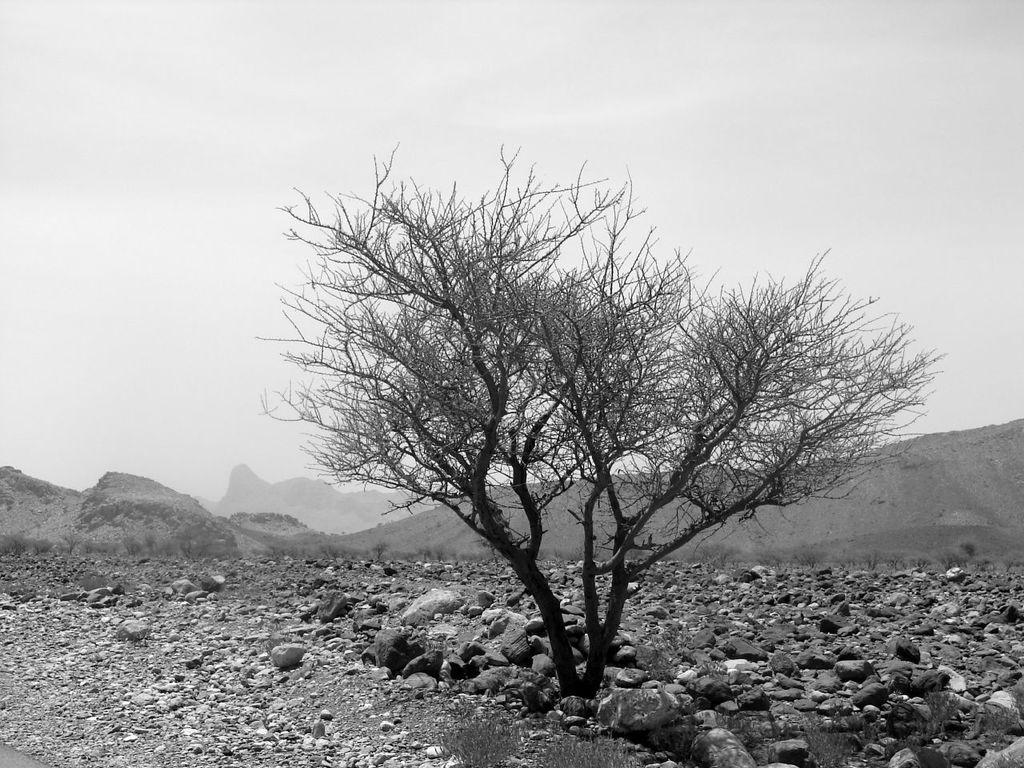Describe this image in one or two sentences. In this image in the front there are stones on the ground. In the center there is a tree and in the background there are mountains and the sky is cloudy. 